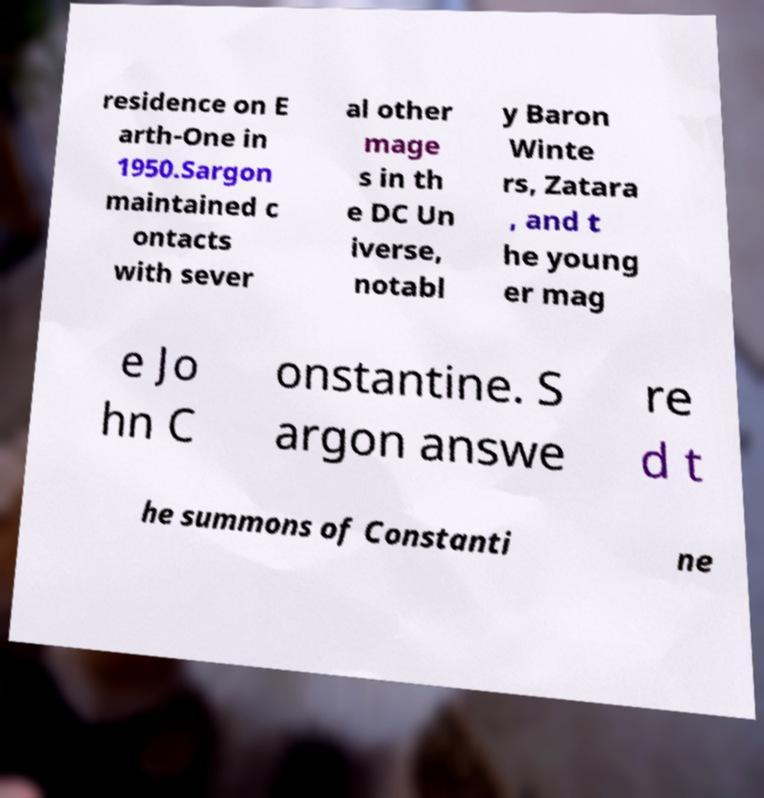Please identify and transcribe the text found in this image. residence on E arth-One in 1950.Sargon maintained c ontacts with sever al other mage s in th e DC Un iverse, notabl y Baron Winte rs, Zatara , and t he young er mag e Jo hn C onstantine. S argon answe re d t he summons of Constanti ne 